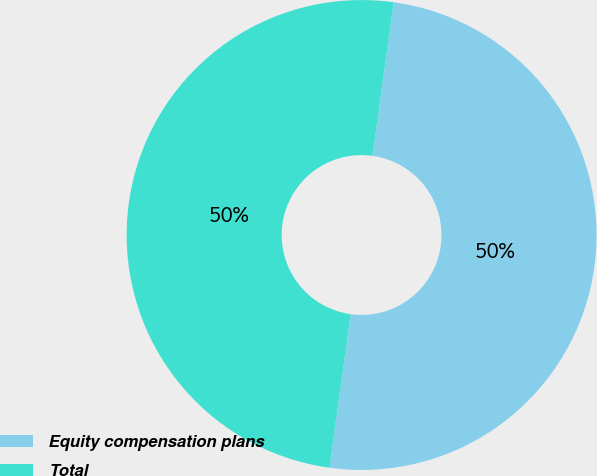<chart> <loc_0><loc_0><loc_500><loc_500><pie_chart><fcel>Equity compensation plans<fcel>Total<nl><fcel>50.0%<fcel>50.0%<nl></chart> 